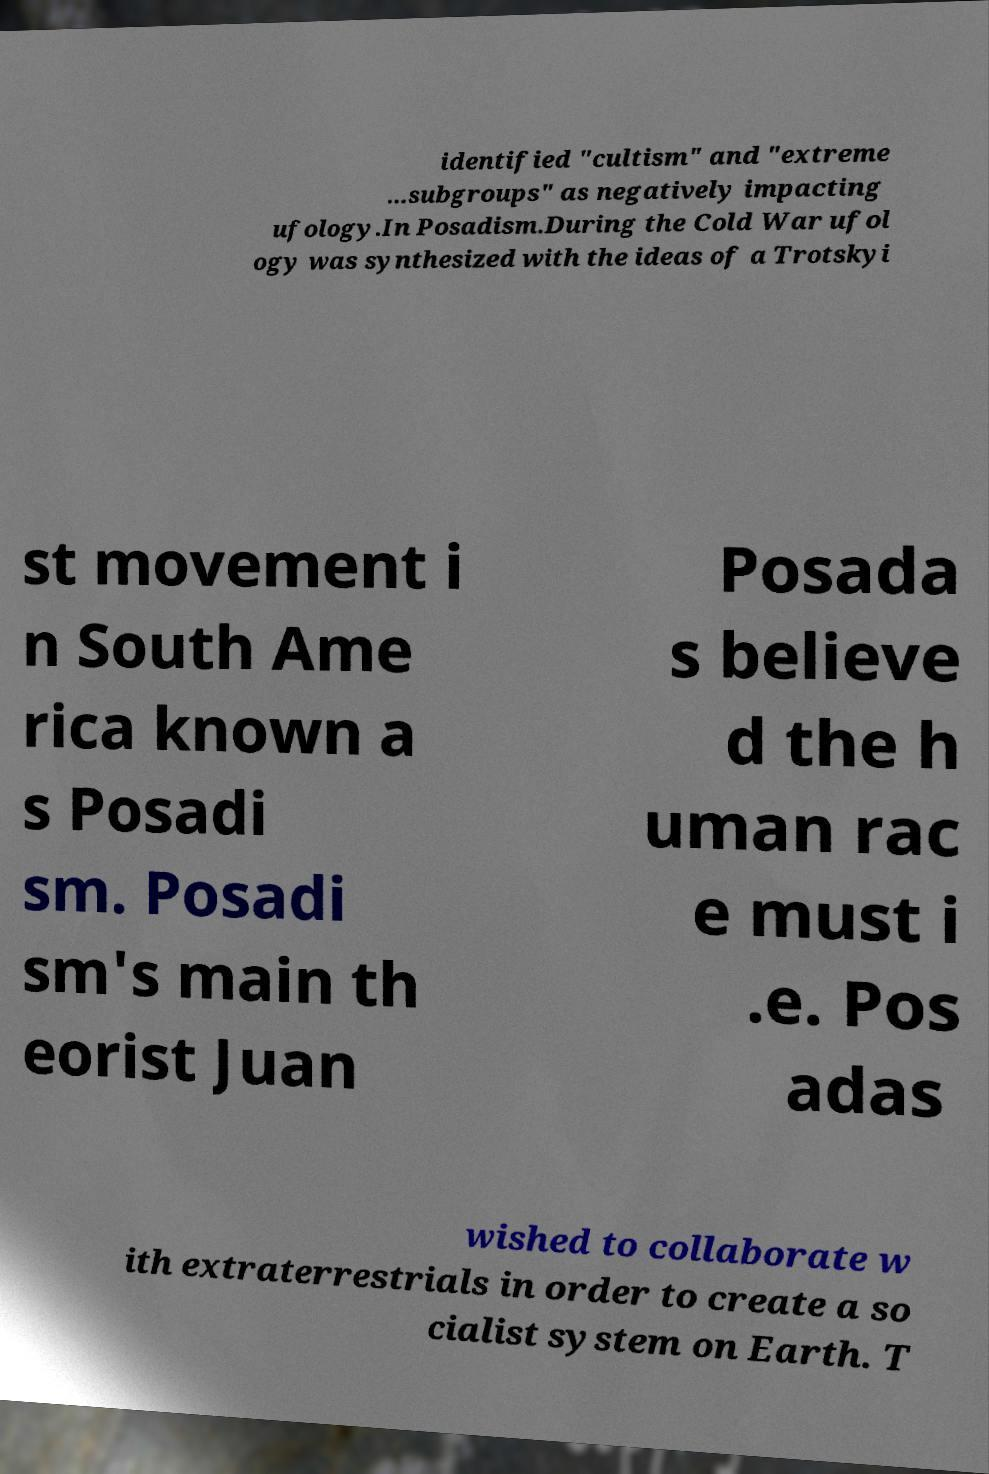For documentation purposes, I need the text within this image transcribed. Could you provide that? identified "cultism" and "extreme ...subgroups" as negatively impacting ufology.In Posadism.During the Cold War ufol ogy was synthesized with the ideas of a Trotskyi st movement i n South Ame rica known a s Posadi sm. Posadi sm's main th eorist Juan Posada s believe d the h uman rac e must i .e. Pos adas wished to collaborate w ith extraterrestrials in order to create a so cialist system on Earth. T 